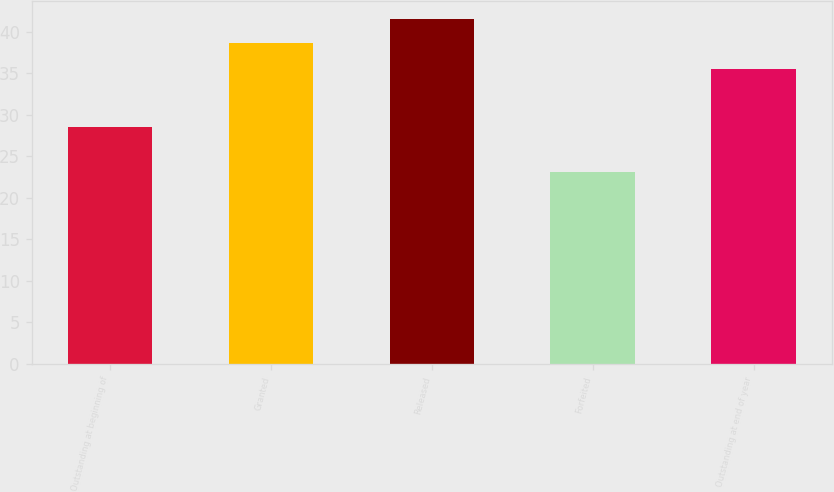Convert chart to OTSL. <chart><loc_0><loc_0><loc_500><loc_500><bar_chart><fcel>Outstanding at beginning of<fcel>Granted<fcel>Released<fcel>Forfeited<fcel>Outstanding at end of year<nl><fcel>28.58<fcel>38.68<fcel>41.57<fcel>23.06<fcel>35.55<nl></chart> 